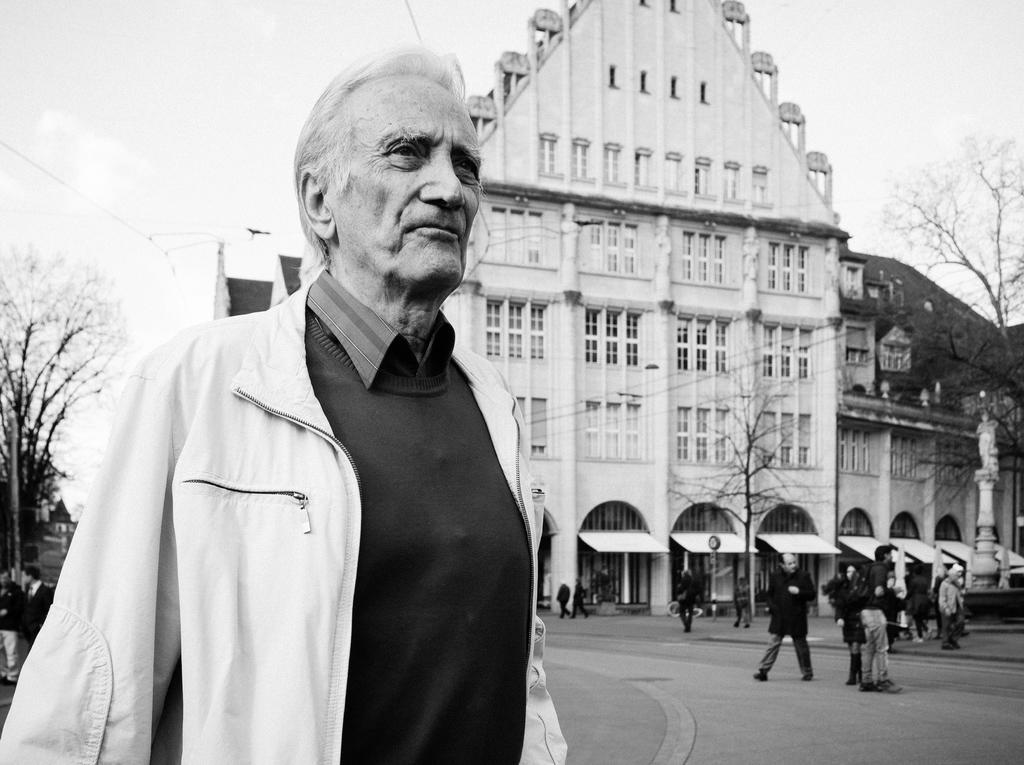How would you summarize this image in a sentence or two? In this picture we can see the road, some people, sunshades, trees, building with windows and in the background we can see the sky. 